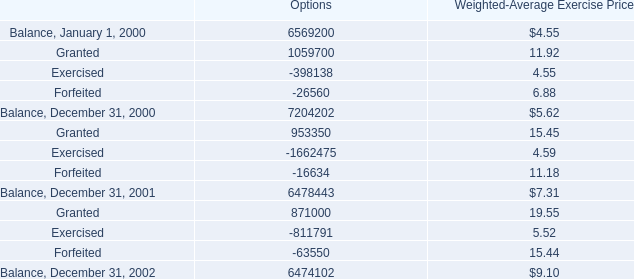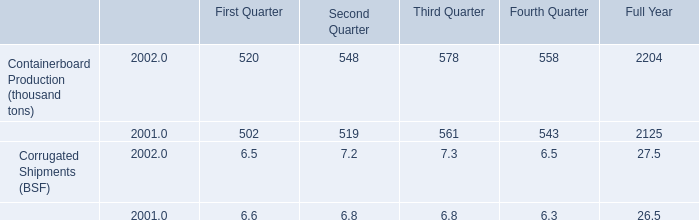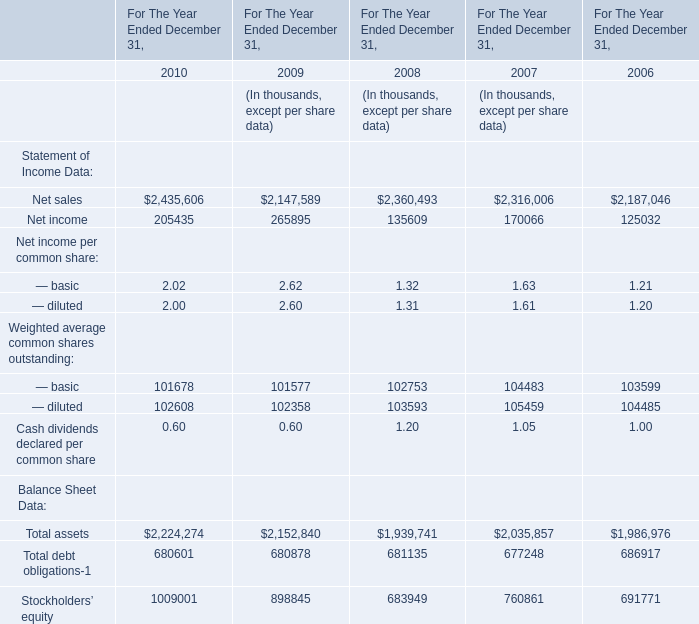What is the total amount of Net income of For The Year Ended December 31, 2010, and Balance, January 1, 2000 of Options ? 
Computations: (205435.0 + 6569200.0)
Answer: 6774635.0. 